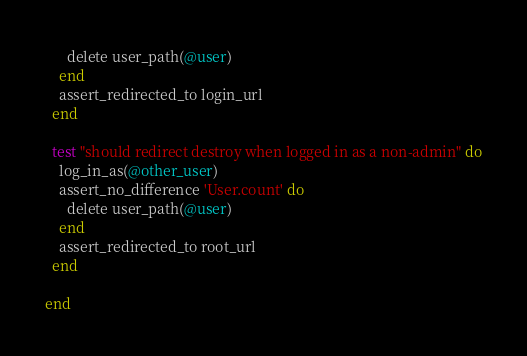Convert code to text. <code><loc_0><loc_0><loc_500><loc_500><_Ruby_>      delete user_path(@user)
    end
    assert_redirected_to login_url
  end

  test "should redirect destroy when logged in as a non-admin" do
    log_in_as(@other_user)
    assert_no_difference 'User.count' do
      delete user_path(@user)
    end
    assert_redirected_to root_url
  end

end
</code> 